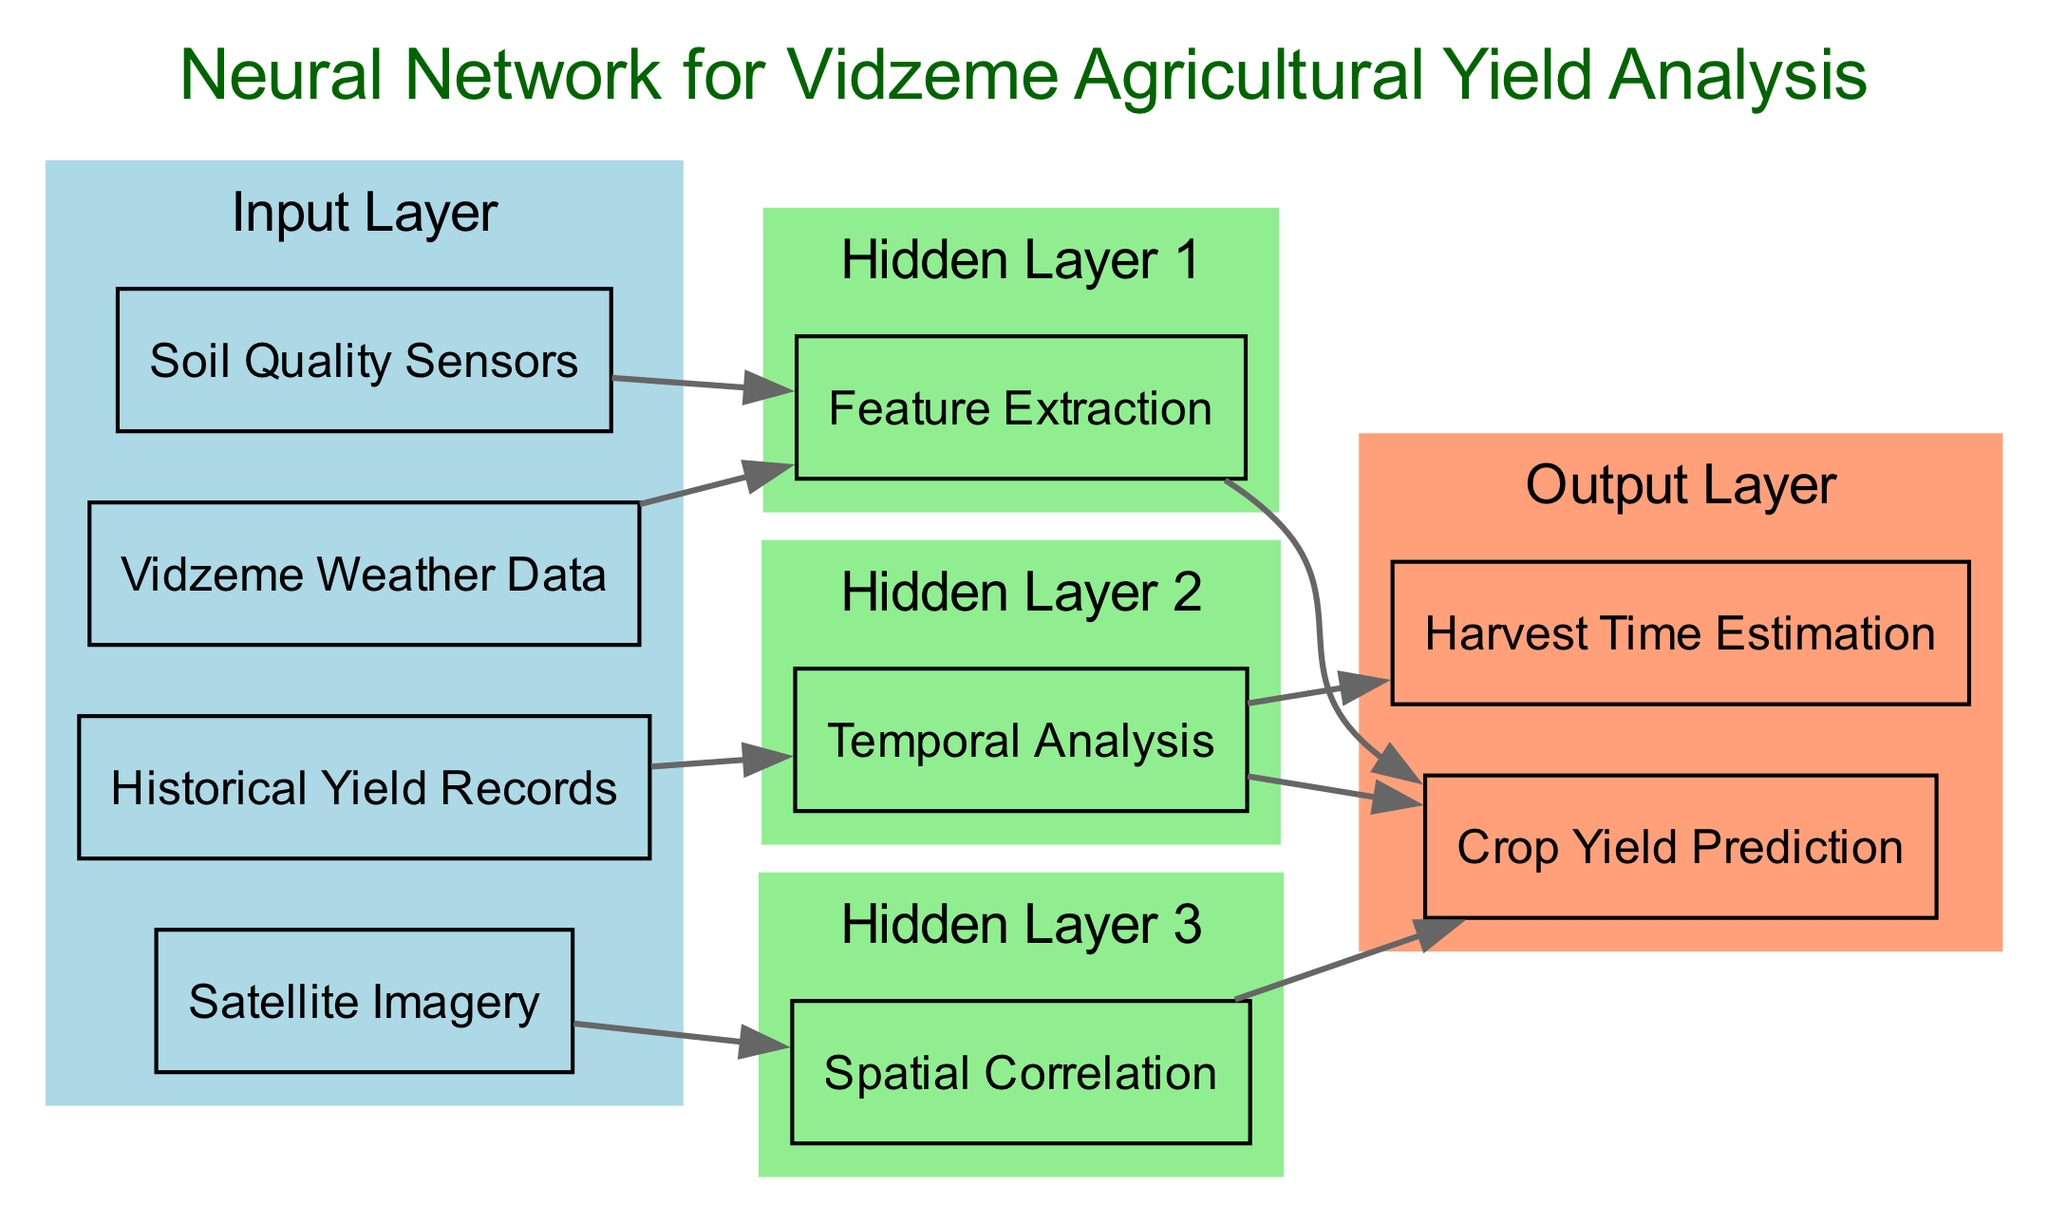What are the input nodes of the neural network? The input nodes are explicitly listed in the diagram: Vidzeme Weather Data, Soil Quality Sensors, Historical Yield Records, and Satellite Imagery.
Answer: Vidzeme Weather Data, Soil Quality Sensors, Historical Yield Records, Satellite Imagery How many hidden layers are there in the architecture? The diagram displays three hidden layers: Feature Extraction, Temporal Analysis, and Spatial Correlation. Counting these layers provides the answer.
Answer: 3 Which input node connects to the Feature Extraction layer? Both Vidzeme Weather Data and Soil Quality Sensors connect to the Feature Extraction layer, as indicated by their connections in the diagram.
Answer: Vidzeme Weather Data, Soil Quality Sensors What is the output of the neural network? The outputs are listed in the output layer of the diagram: Crop Yield Prediction and Harvest Time Estimation. Therefore, they represent the results of the network.
Answer: Crop Yield Prediction, Harvest Time Estimation Which hidden layer is specifically related to analyzing historical data? The Temporal Analysis hidden layer is linked to analyzing historical yield records, as it is the only layer associated with that input.
Answer: Temporal Analysis Which output node does the Temporal Analysis layer feed into? The Temporal Analysis layer feeds into both the Crop Yield Prediction and Harvest Time Estimation nodes, allowing it to impact both outputs.
Answer: Crop Yield Prediction, Harvest Time Estimation How does Satellite Imagery contribute to the model? Satellite Imagery connects to the Spatial Correlation hidden layer, which processes this data to inform the Crop Yield Prediction. This individual contribution demonstrates its role in the model.
Answer: Spatial Correlation Is there a connection between any hidden layers? Yes, the connections show that Feature Extraction feeds into Crop Yield Prediction, and Temporal Analysis also connects to Crop Yield Prediction and Harvest Time Estimation. This indicates inter-layer relationships based on data processing flow.
Answer: Yes What is the significance of having multiple input sources? Multiple input sources allow for a comprehensive analysis of agricultural yields by integrating weather data, soil quality, historical records, and satellite imagery. This multi-faceted approach enhances the model's accuracy and predictive capability.
Answer: Comprehensive analysis of agricultural yields 